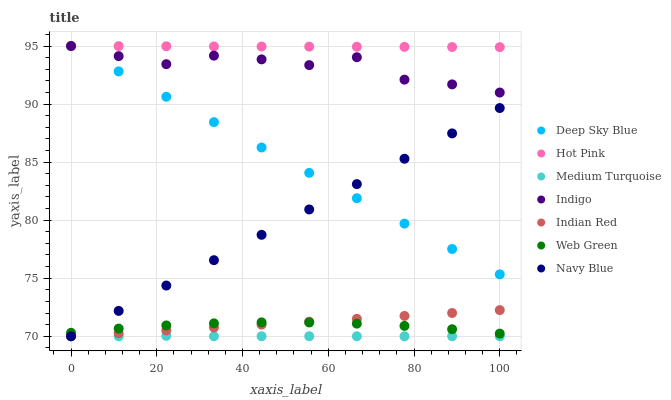Does Medium Turquoise have the minimum area under the curve?
Answer yes or no. Yes. Does Hot Pink have the maximum area under the curve?
Answer yes or no. Yes. Does Navy Blue have the minimum area under the curve?
Answer yes or no. No. Does Navy Blue have the maximum area under the curve?
Answer yes or no. No. Is Navy Blue the smoothest?
Answer yes or no. Yes. Is Indigo the roughest?
Answer yes or no. Yes. Is Medium Turquoise the smoothest?
Answer yes or no. No. Is Medium Turquoise the roughest?
Answer yes or no. No. Does Medium Turquoise have the lowest value?
Answer yes or no. Yes. Does Hot Pink have the lowest value?
Answer yes or no. No. Does Deep Sky Blue have the highest value?
Answer yes or no. Yes. Does Navy Blue have the highest value?
Answer yes or no. No. Is Indian Red less than Indigo?
Answer yes or no. Yes. Is Deep Sky Blue greater than Indian Red?
Answer yes or no. Yes. Does Navy Blue intersect Web Green?
Answer yes or no. Yes. Is Navy Blue less than Web Green?
Answer yes or no. No. Is Navy Blue greater than Web Green?
Answer yes or no. No. Does Indian Red intersect Indigo?
Answer yes or no. No. 